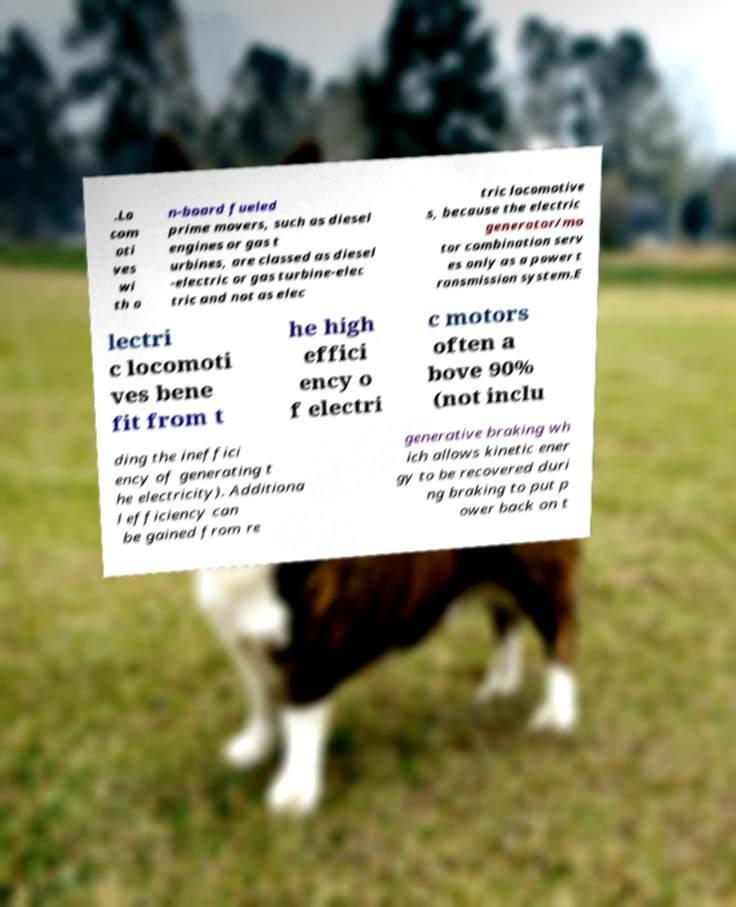For documentation purposes, I need the text within this image transcribed. Could you provide that? .Lo com oti ves wi th o n-board fueled prime movers, such as diesel engines or gas t urbines, are classed as diesel -electric or gas turbine-elec tric and not as elec tric locomotive s, because the electric generator/mo tor combination serv es only as a power t ransmission system.E lectri c locomoti ves bene fit from t he high effici ency o f electri c motors often a bove 90% (not inclu ding the ineffici ency of generating t he electricity). Additiona l efficiency can be gained from re generative braking wh ich allows kinetic ener gy to be recovered duri ng braking to put p ower back on t 